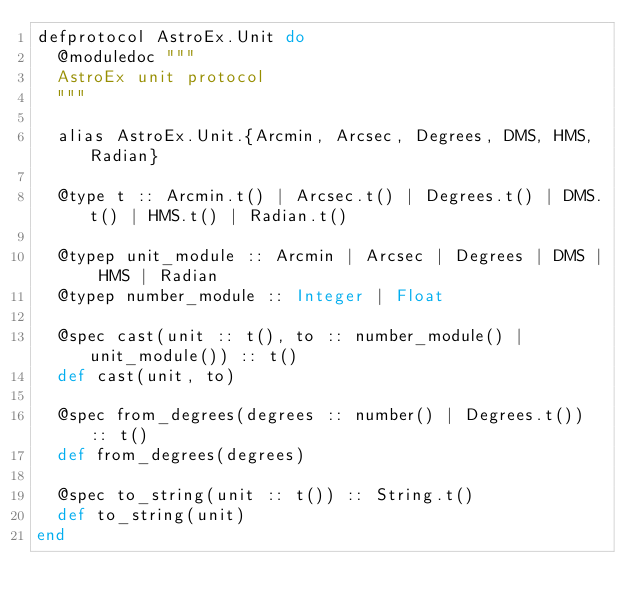<code> <loc_0><loc_0><loc_500><loc_500><_Elixir_>defprotocol AstroEx.Unit do
  @moduledoc """
  AstroEx unit protocol
  """

  alias AstroEx.Unit.{Arcmin, Arcsec, Degrees, DMS, HMS, Radian}

  @type t :: Arcmin.t() | Arcsec.t() | Degrees.t() | DMS.t() | HMS.t() | Radian.t()

  @typep unit_module :: Arcmin | Arcsec | Degrees | DMS | HMS | Radian
  @typep number_module :: Integer | Float

  @spec cast(unit :: t(), to :: number_module() | unit_module()) :: t()
  def cast(unit, to)

  @spec from_degrees(degrees :: number() | Degrees.t()) :: t()
  def from_degrees(degrees)

  @spec to_string(unit :: t()) :: String.t()
  def to_string(unit)
end
</code> 